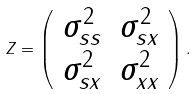Convert formula to latex. <formula><loc_0><loc_0><loc_500><loc_500>Z = \left ( \begin{array} { c c } \sigma _ { s s } ^ { 2 } & \sigma _ { s x } ^ { 2 } \\ \sigma _ { s x } ^ { 2 } & \sigma _ { x x } ^ { 2 } \end{array} \right ) .</formula> 